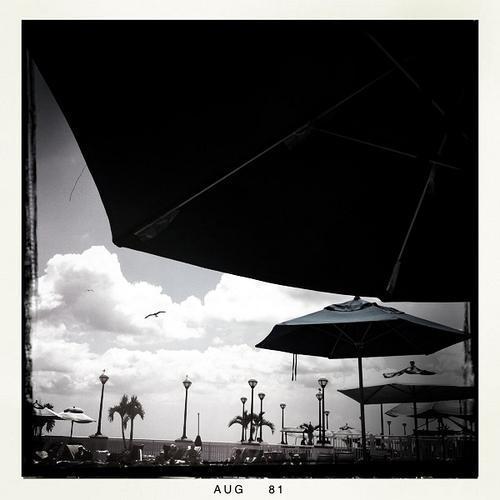How many birds are flying in the sky?
Give a very brief answer. 1. 